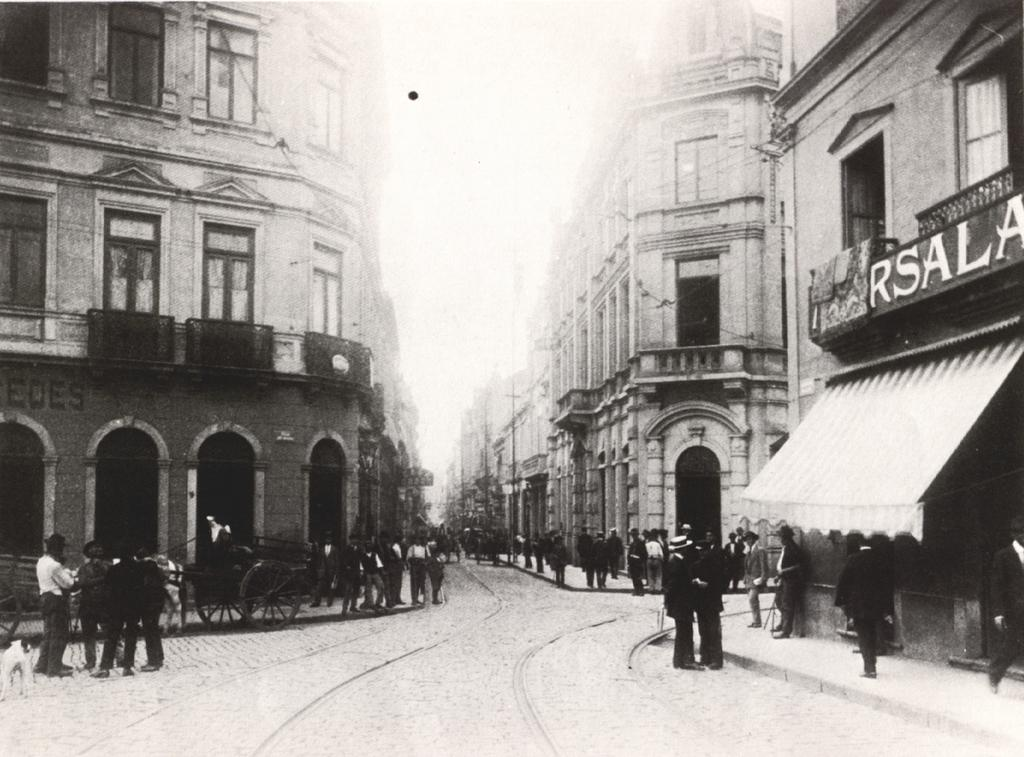What type of structures can be seen in the image? There are buildings in the image. What feature of the buildings is visible in the image? There are windows visible in the image. What objects are present in the image that are not part of the buildings? There are poles in the image. Who or what else can be seen in the image? There are people in the image. What is happening on the road in the image? There are vehicles on the road in the image. What is the color scheme of the image? The image is in black and white. Can you tell me what type of argument is taking place between the waves in the image? There are no waves present in the image, so it is not possible to determine if an argument is taking place. 